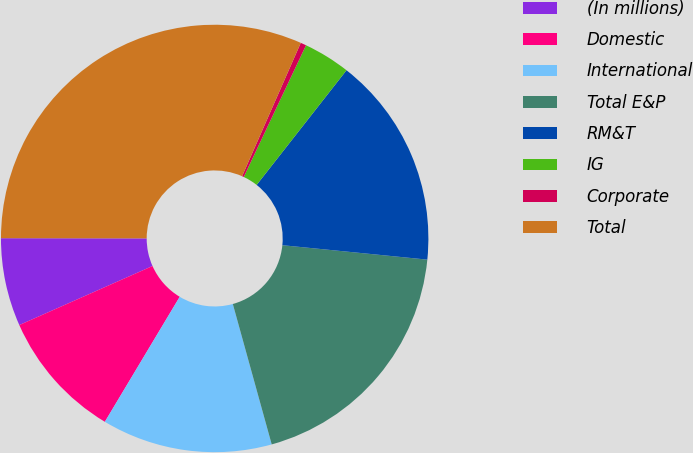Convert chart. <chart><loc_0><loc_0><loc_500><loc_500><pie_chart><fcel>(In millions)<fcel>Domestic<fcel>International<fcel>Total E&P<fcel>RM&T<fcel>IG<fcel>Corporate<fcel>Total<nl><fcel>6.66%<fcel>9.77%<fcel>12.89%<fcel>19.12%<fcel>16.0%<fcel>3.55%<fcel>0.43%<fcel>31.58%<nl></chart> 